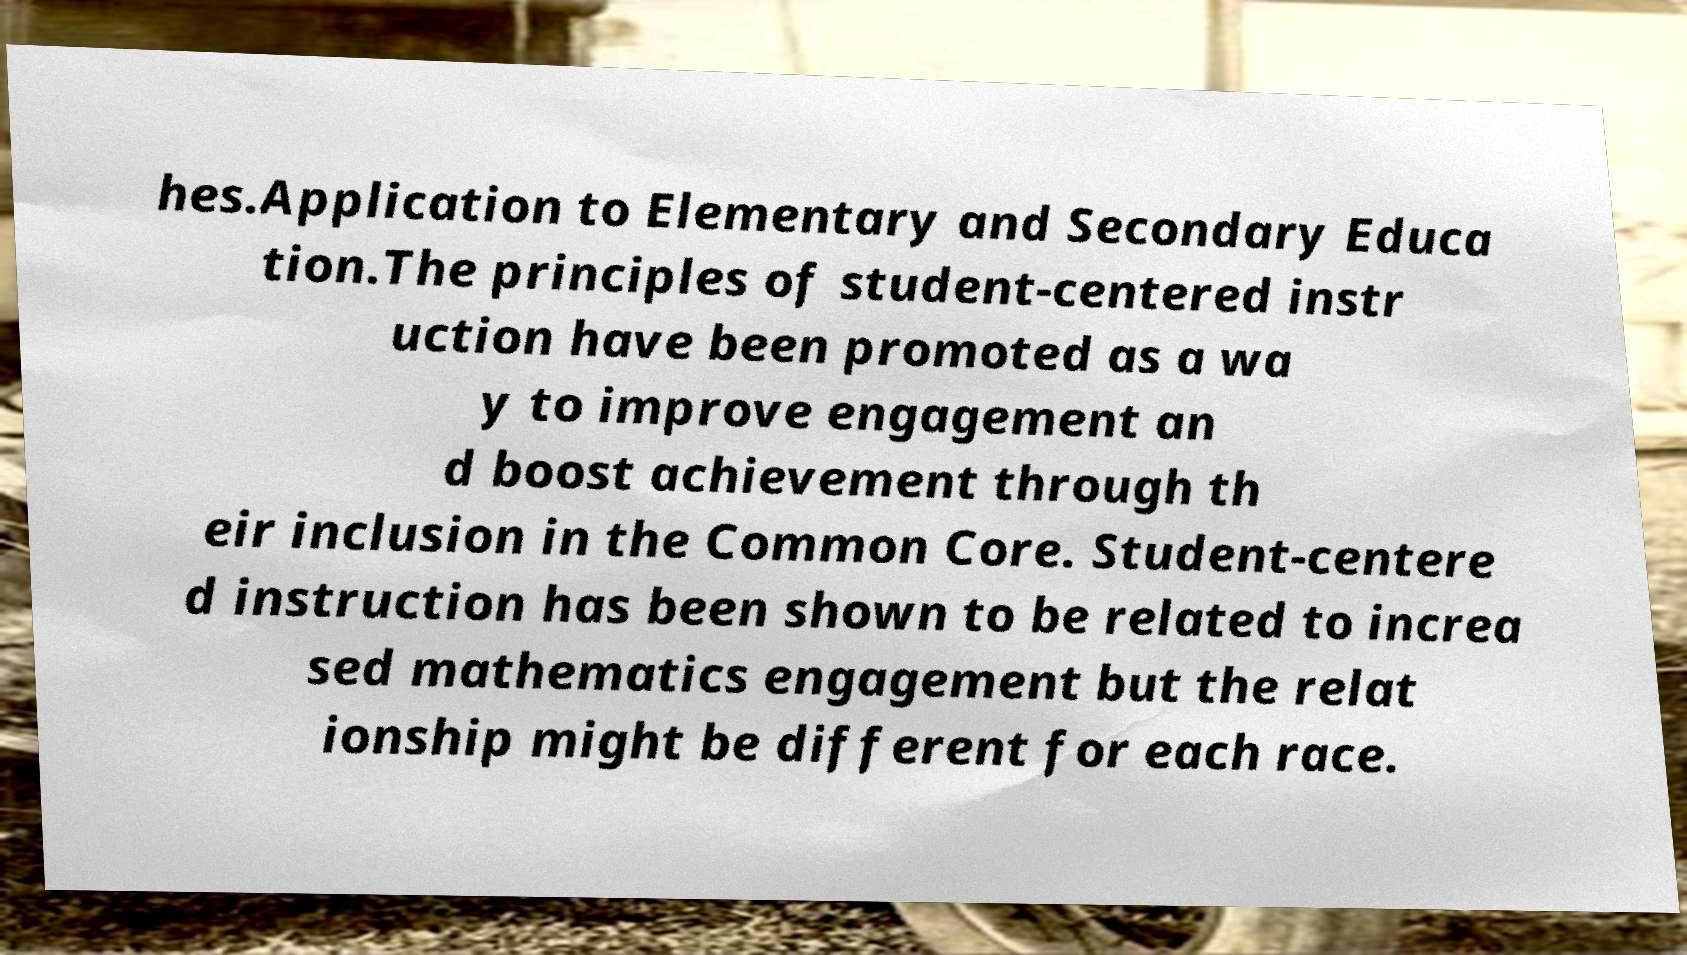There's text embedded in this image that I need extracted. Can you transcribe it verbatim? hes.Application to Elementary and Secondary Educa tion.The principles of student-centered instr uction have been promoted as a wa y to improve engagement an d boost achievement through th eir inclusion in the Common Core. Student-centere d instruction has been shown to be related to increa sed mathematics engagement but the relat ionship might be different for each race. 